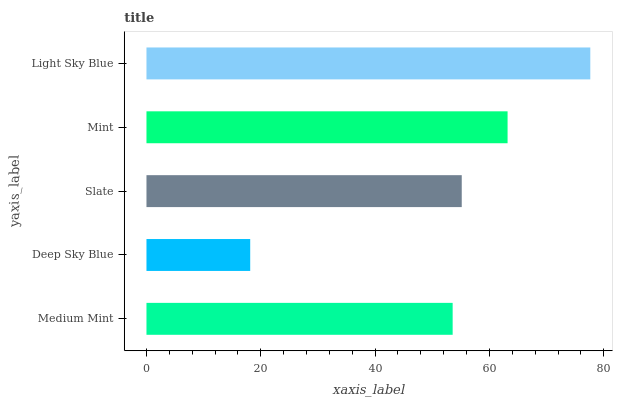Is Deep Sky Blue the minimum?
Answer yes or no. Yes. Is Light Sky Blue the maximum?
Answer yes or no. Yes. Is Slate the minimum?
Answer yes or no. No. Is Slate the maximum?
Answer yes or no. No. Is Slate greater than Deep Sky Blue?
Answer yes or no. Yes. Is Deep Sky Blue less than Slate?
Answer yes or no. Yes. Is Deep Sky Blue greater than Slate?
Answer yes or no. No. Is Slate less than Deep Sky Blue?
Answer yes or no. No. Is Slate the high median?
Answer yes or no. Yes. Is Slate the low median?
Answer yes or no. Yes. Is Mint the high median?
Answer yes or no. No. Is Medium Mint the low median?
Answer yes or no. No. 